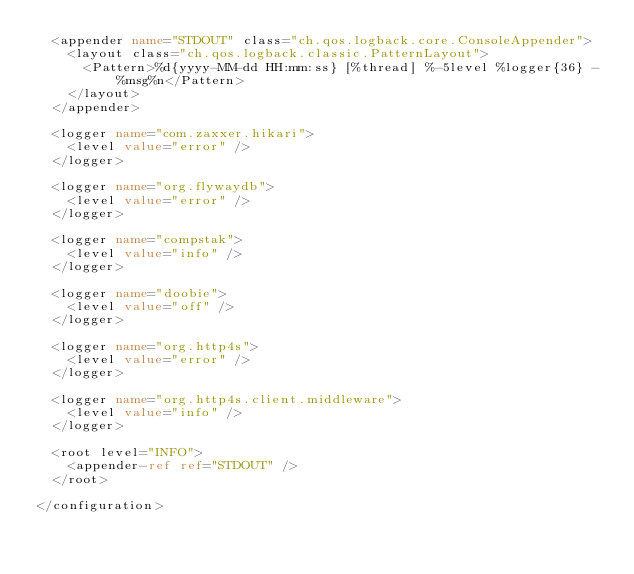<code> <loc_0><loc_0><loc_500><loc_500><_XML_>  <appender name="STDOUT" class="ch.qos.logback.core.ConsoleAppender">
    <layout class="ch.qos.logback.classic.PatternLayout">
      <Pattern>%d{yyyy-MM-dd HH:mm:ss} [%thread] %-5level %logger{36} - %msg%n</Pattern>
    </layout>
  </appender>

  <logger name="com.zaxxer.hikari">
    <level value="error" />
  </logger>

  <logger name="org.flywaydb">
    <level value="error" />
  </logger>
  
  <logger name="compstak">
    <level value="info" />
  </logger>

  <logger name="doobie">
    <level value="off" />
  </logger>

  <logger name="org.http4s">
    <level value="error" />
  </logger>

  <logger name="org.http4s.client.middleware">
    <level value="info" />
  </logger>

  <root level="INFO">
    <appender-ref ref="STDOUT" />
  </root>

</configuration></code> 